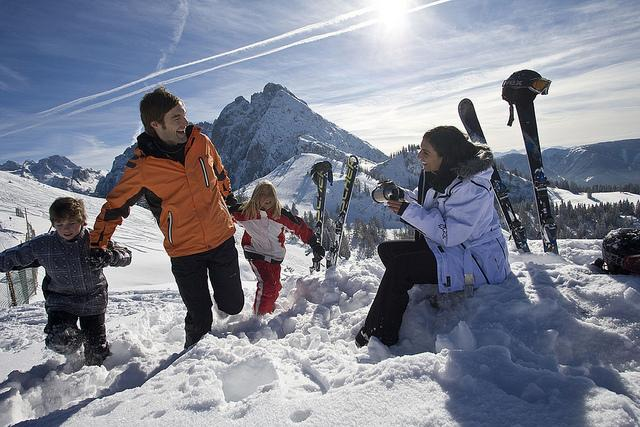What would be the most appropriate beverage for the family to have? hot chocolate 